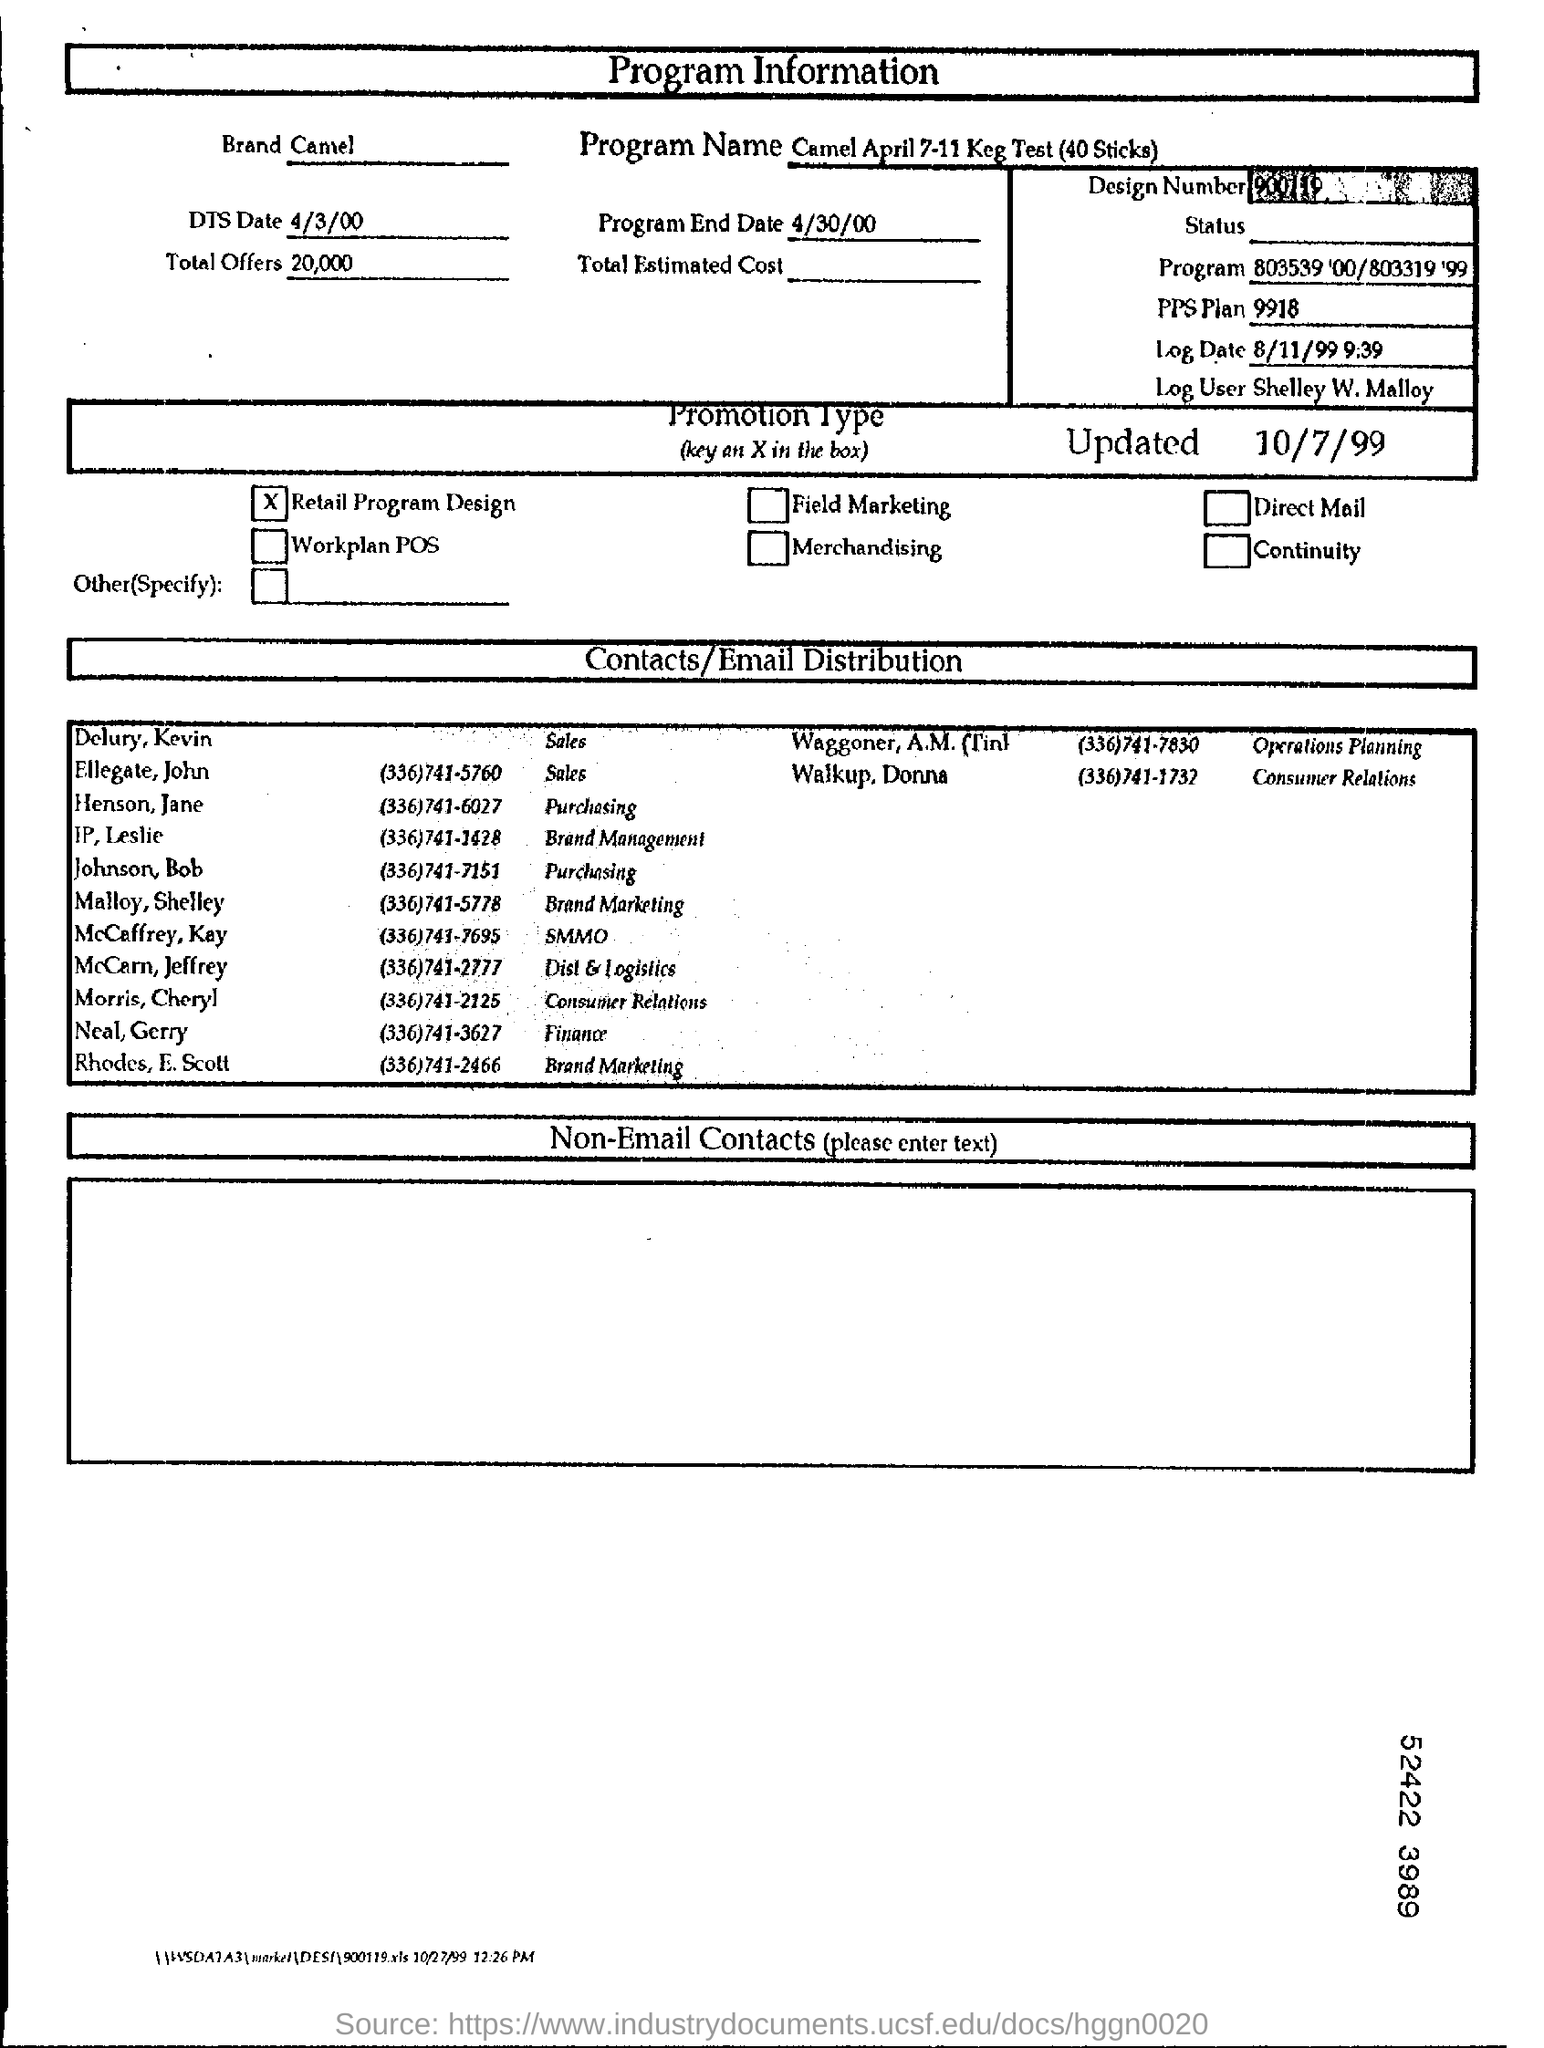Draw attention to some important aspects in this diagram. The program name is Camel April 7-11 Keg Test (40 Sticks)." has been converted to: "The program in question is named Camel and was conducted from April 7-11, 2023, with a keg as the testing device and 40 sticks as the test units. The promotion type is retail program design. It is Morris and Cheryl who are responsible for Consumer Relations. The individual identified as Shelley W. Malloy is the log user. The program will end on April 30, 2000. 